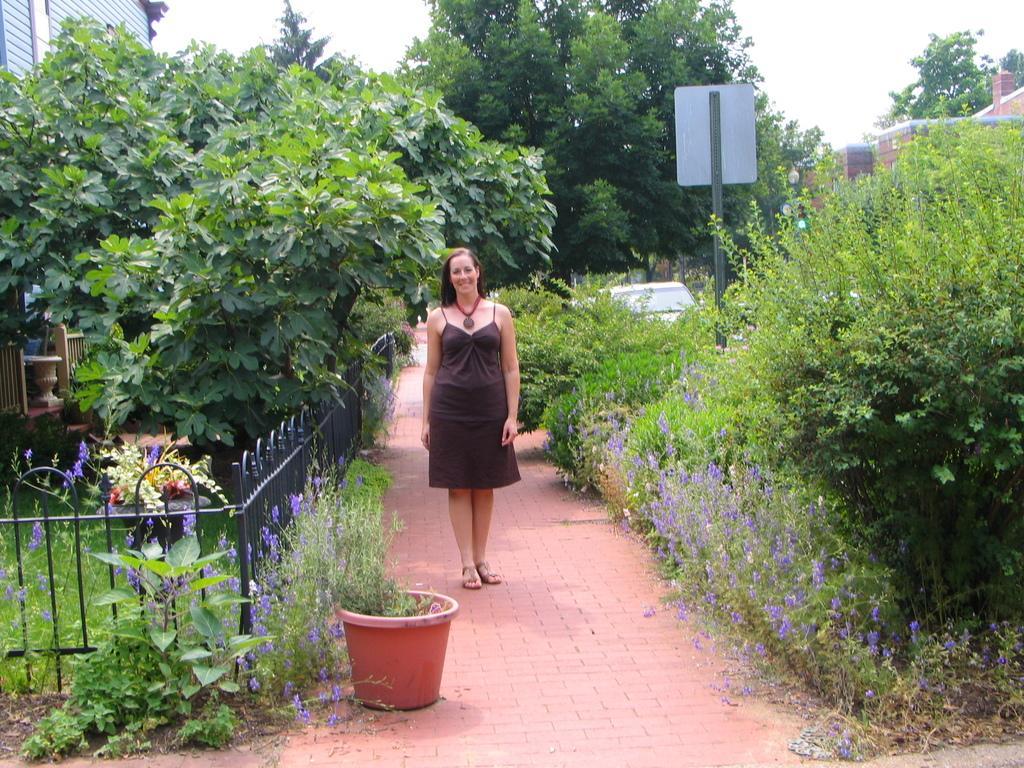Could you give a brief overview of what you see in this image? In the picture we can see a path with tiles and a woman standing on it she is with black dress and smile and beside her left hand side we can see some plants and violet color flowers to it and behind it we can see a railing and behind it we can see some plants and on the right hand side of a woman we can see some plants with violet color flowers, and a part of car and in the background we can see a tree and a sky. 